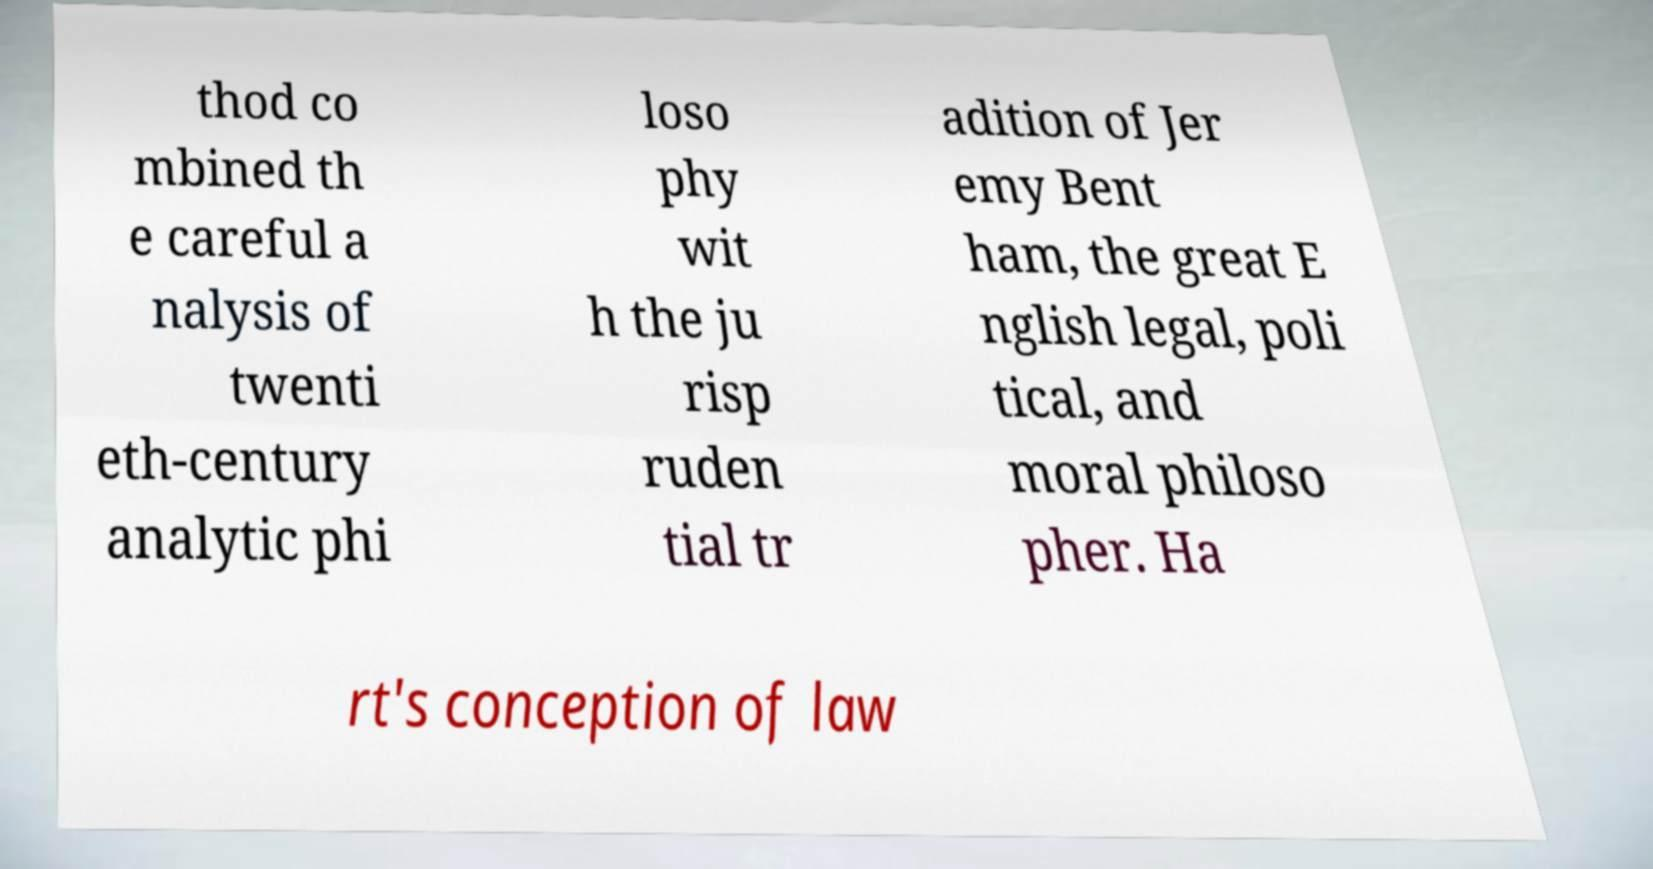I need the written content from this picture converted into text. Can you do that? thod co mbined th e careful a nalysis of twenti eth-century analytic phi loso phy wit h the ju risp ruden tial tr adition of Jer emy Bent ham, the great E nglish legal, poli tical, and moral philoso pher. Ha rt's conception of law 